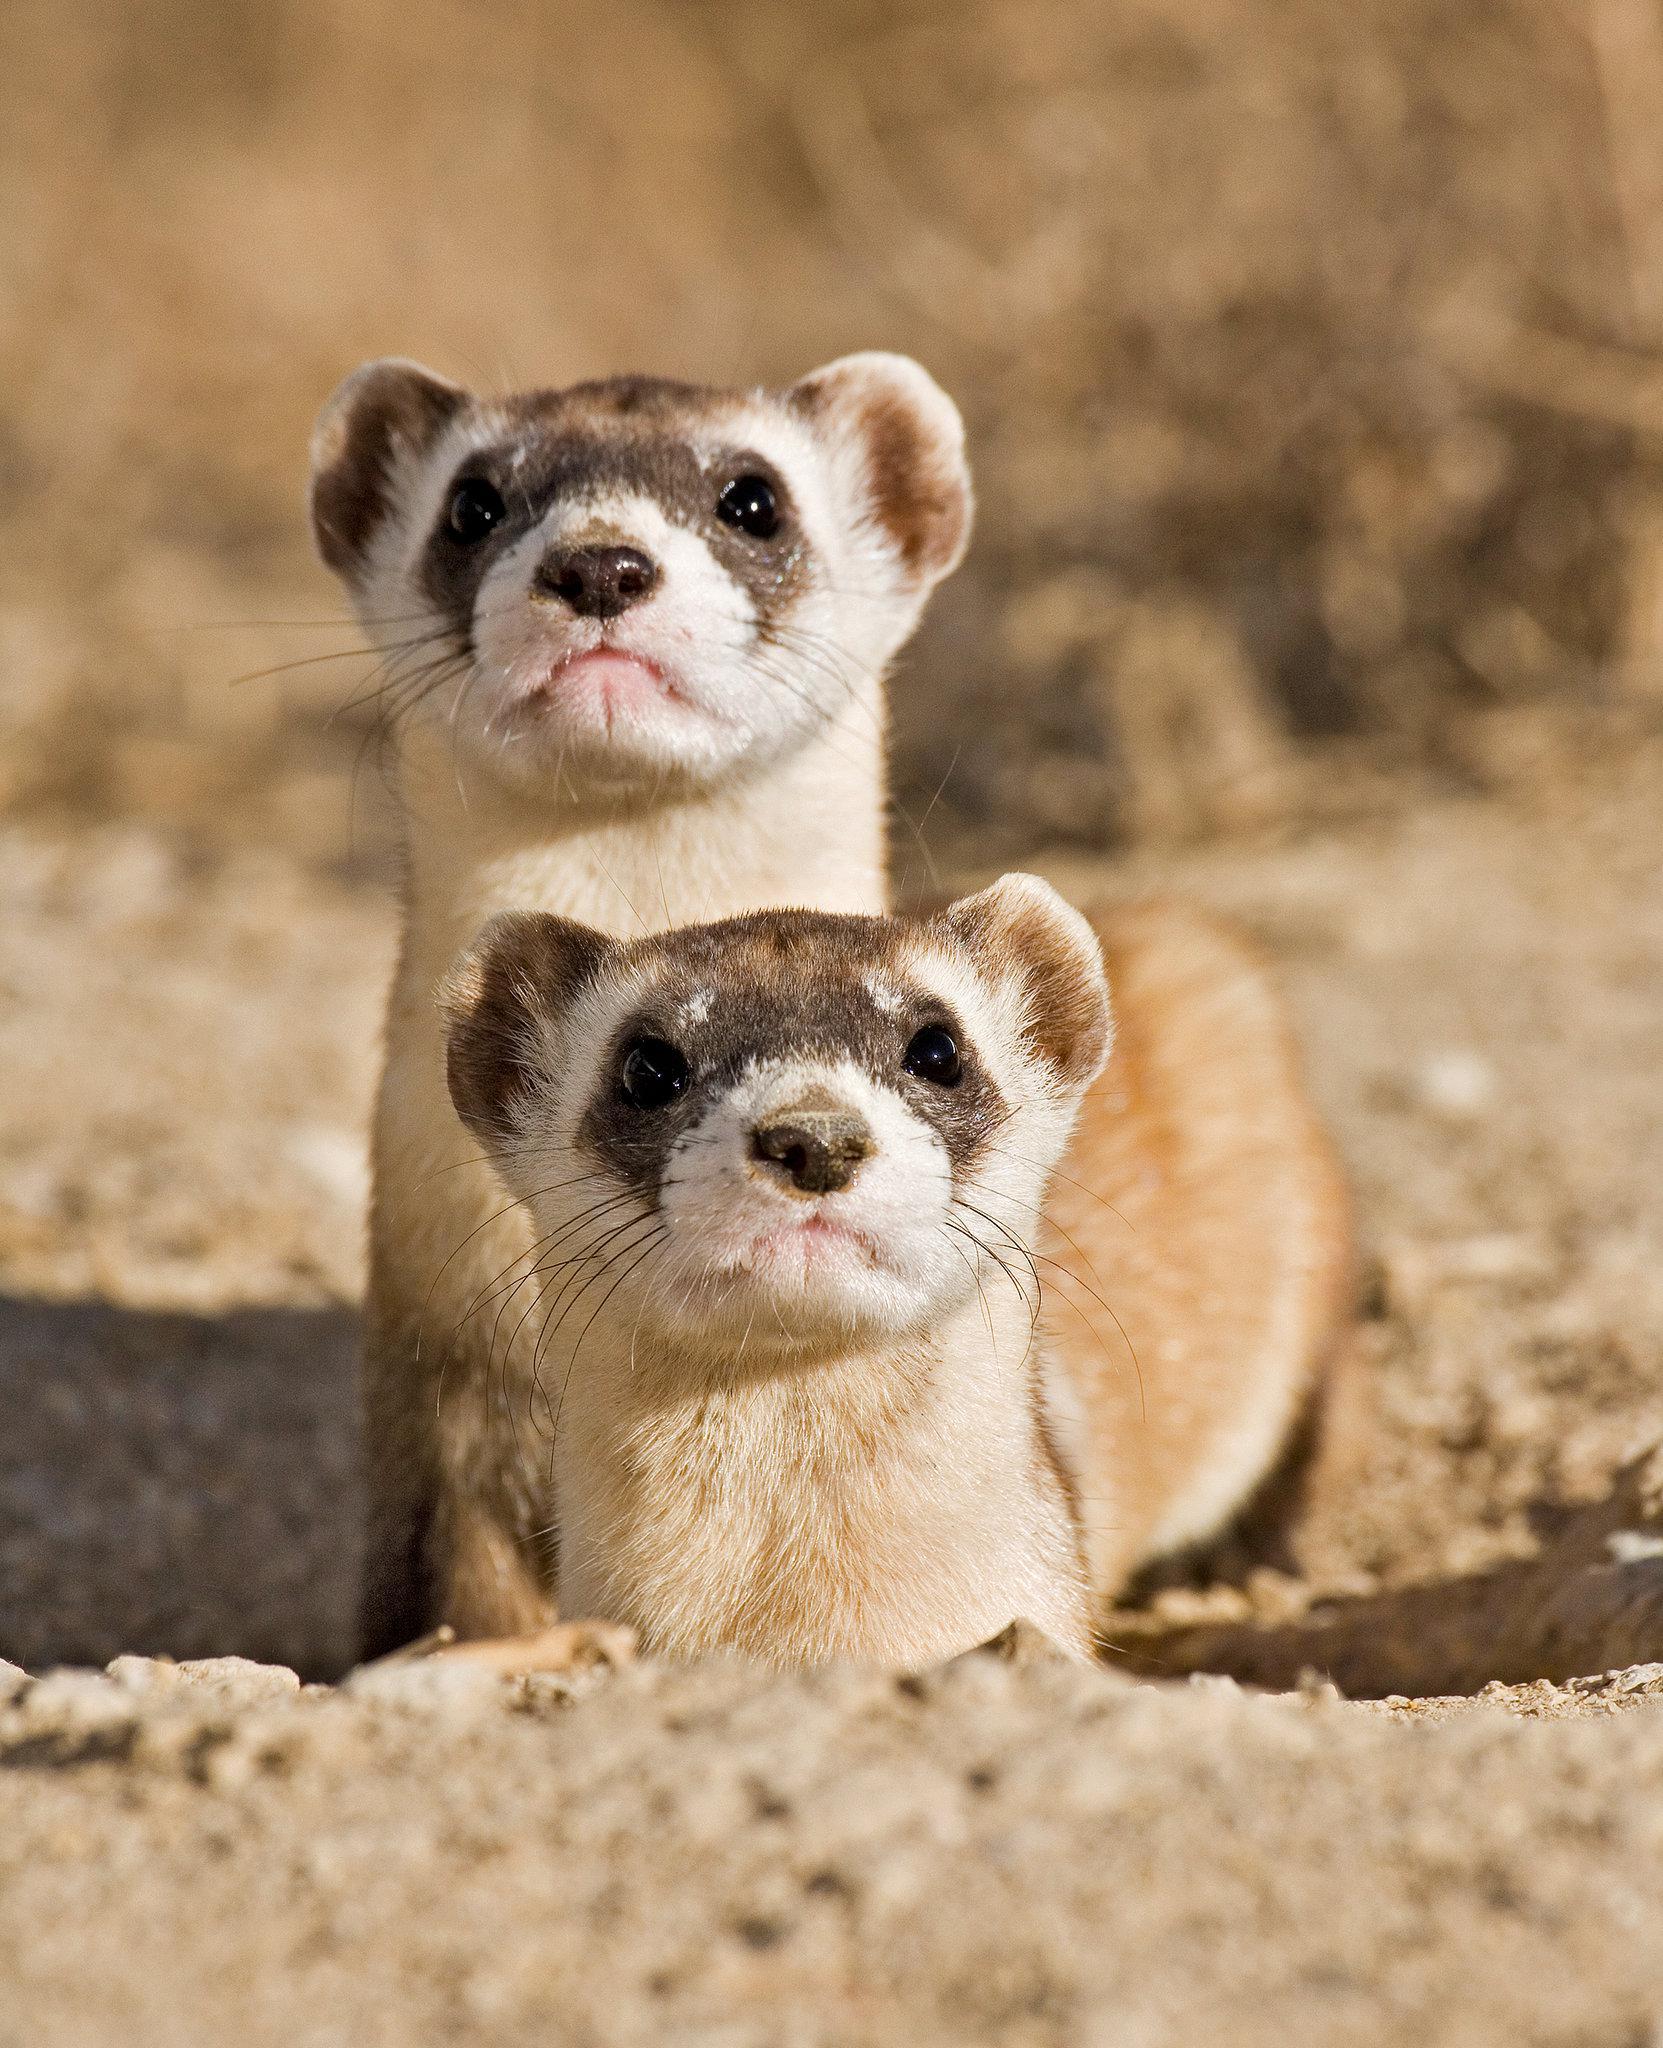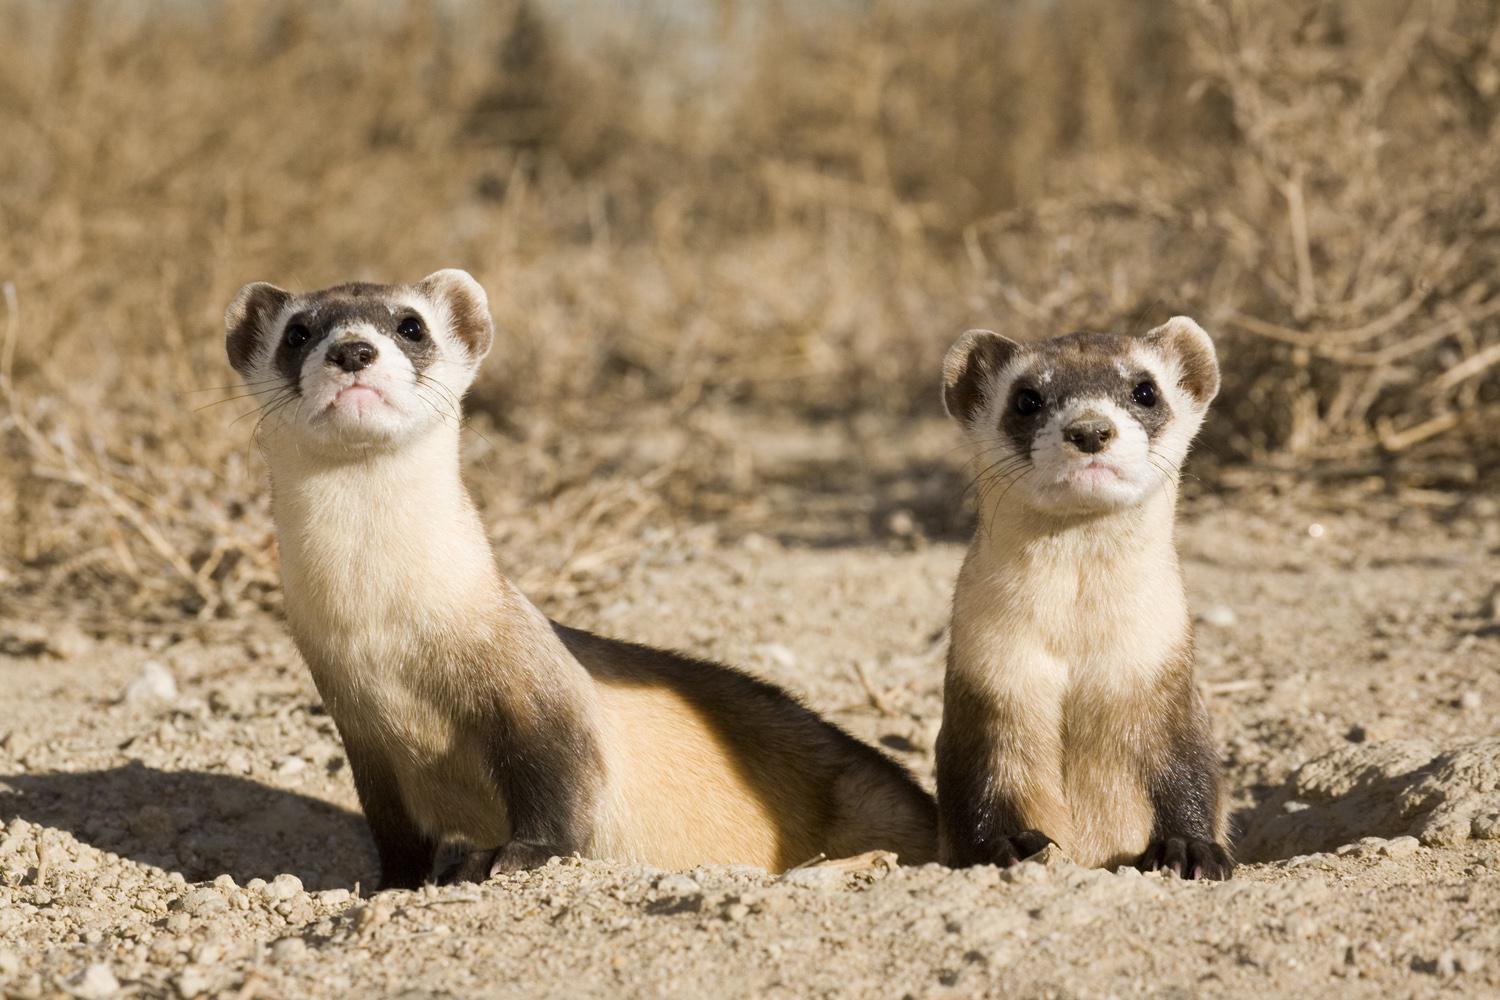The first image is the image on the left, the second image is the image on the right. Analyze the images presented: Is the assertion "In one image of each pair an animal is looking towards (the image viewers) left." valid? Answer yes or no. No. 